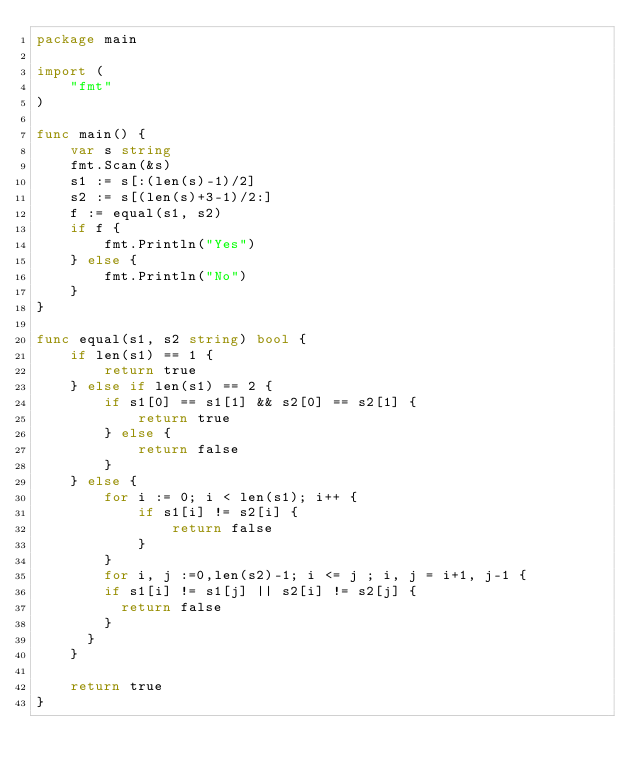Convert code to text. <code><loc_0><loc_0><loc_500><loc_500><_Go_>package main

import (
	"fmt"
)

func main() {
	var s string
	fmt.Scan(&s)
	s1 := s[:(len(s)-1)/2]
	s2 := s[(len(s)+3-1)/2:]
	f := equal(s1, s2)
	if f {
		fmt.Println("Yes")
	} else {
		fmt.Println("No")
	}
}

func equal(s1, s2 string) bool {
	if len(s1) == 1 {
		return true
	} else if len(s1) == 2 {
		if s1[0] == s1[1] && s2[0] == s2[1] {
			return true
		} else {
			return false
		}
	} else {
		for i := 0; i < len(s1); i++ {
			if s1[i] != s2[i] {
				return false
			}
		}
        for i, j :=0,len(s2)-1; i <= j ; i, j = i+1, j-1 {
        if s1[i] != s1[j] || s2[i] != s2[j] {
          return false
        }
      }
	}

	return true
}


</code> 